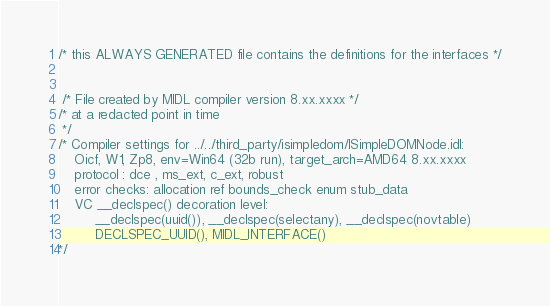Convert code to text. <code><loc_0><loc_0><loc_500><loc_500><_C_>

/* this ALWAYS GENERATED file contains the definitions for the interfaces */


 /* File created by MIDL compiler version 8.xx.xxxx */
/* at a redacted point in time
 */
/* Compiler settings for ../../third_party/isimpledom/ISimpleDOMNode.idl:
    Oicf, W1, Zp8, env=Win64 (32b run), target_arch=AMD64 8.xx.xxxx 
    protocol : dce , ms_ext, c_ext, robust
    error checks: allocation ref bounds_check enum stub_data 
    VC __declspec() decoration level: 
         __declspec(uuid()), __declspec(selectany), __declspec(novtable)
         DECLSPEC_UUID(), MIDL_INTERFACE()
*/</code> 